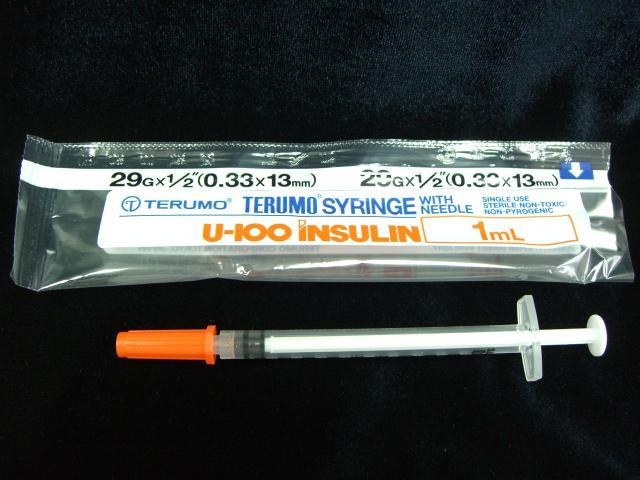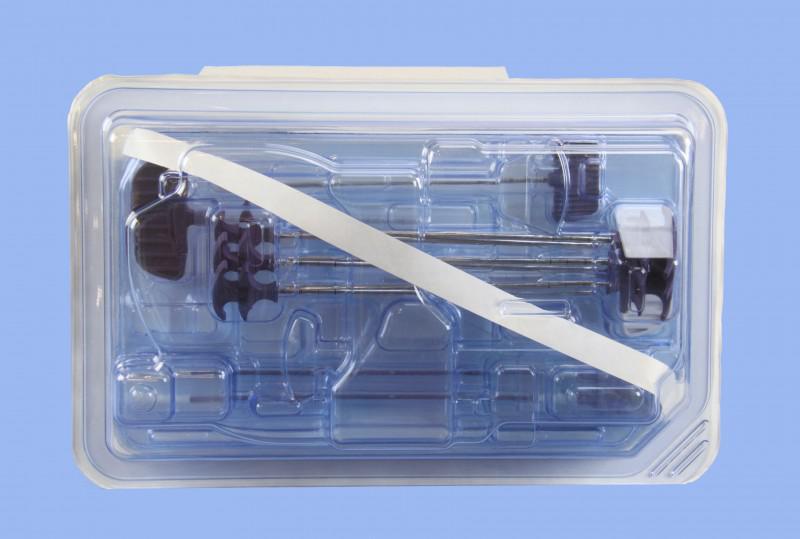The first image is the image on the left, the second image is the image on the right. Analyze the images presented: Is the assertion "The right image shows a pair of syringes that have been used to construct some sort of mechanism with a wheel on it." valid? Answer yes or no. No. The first image is the image on the left, the second image is the image on the right. For the images displayed, is the sentence "One syringe is in front of a rectangular item in one image." factually correct? Answer yes or no. Yes. 